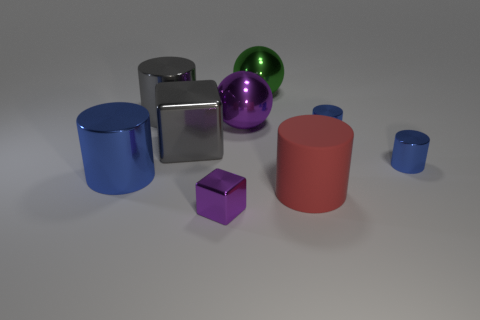There is a metallic object that is the same color as the tiny shiny block; what is its shape?
Provide a short and direct response. Sphere. The large blue metallic object is what shape?
Provide a short and direct response. Cylinder. Are there fewer gray blocks that are in front of the tiny purple object than large gray cylinders?
Provide a short and direct response. Yes. Is there a purple shiny thing that has the same shape as the large green metal thing?
Give a very brief answer. Yes. What shape is the gray metal object that is the same size as the gray block?
Make the answer very short. Cylinder. How many things are either tiny yellow metallic things or purple shiny spheres?
Offer a very short reply. 1. Is there a large yellow shiny cylinder?
Your answer should be very brief. No. Are there fewer blue spheres than tiny metal cylinders?
Offer a terse response. Yes. Is there a purple sphere of the same size as the gray cylinder?
Your answer should be very brief. Yes. Does the large blue metallic object have the same shape as the metallic object in front of the large red object?
Ensure brevity in your answer.  No. 